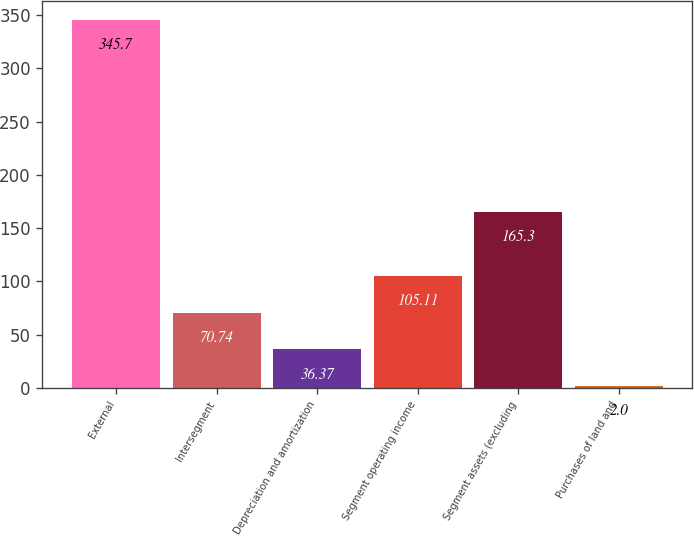Convert chart. <chart><loc_0><loc_0><loc_500><loc_500><bar_chart><fcel>External<fcel>Intersegment<fcel>Depreciation and amortization<fcel>Segment operating income<fcel>Segment assets (excluding<fcel>Purchases of land and<nl><fcel>345.7<fcel>70.74<fcel>36.37<fcel>105.11<fcel>165.3<fcel>2<nl></chart> 